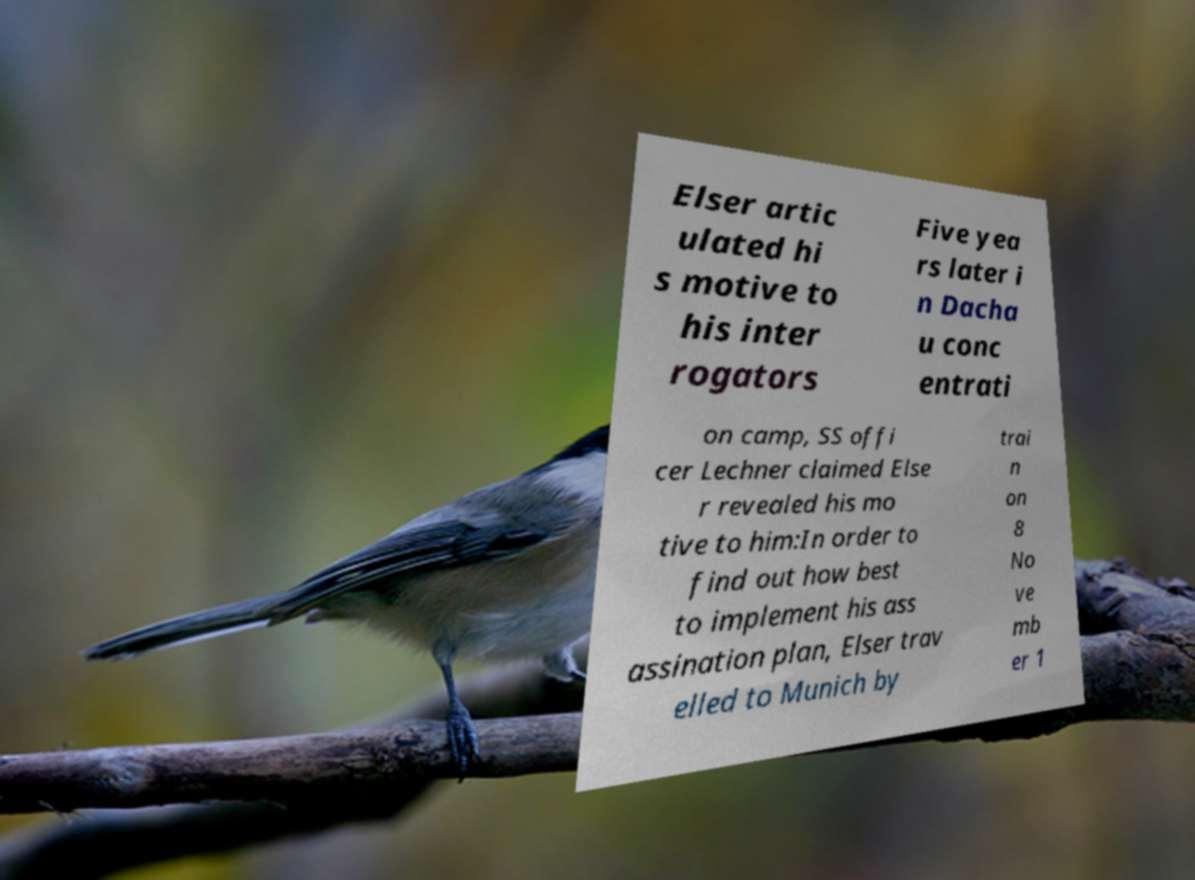What messages or text are displayed in this image? I need them in a readable, typed format. Elser artic ulated hi s motive to his inter rogators Five yea rs later i n Dacha u conc entrati on camp, SS offi cer Lechner claimed Else r revealed his mo tive to him:In order to find out how best to implement his ass assination plan, Elser trav elled to Munich by trai n on 8 No ve mb er 1 